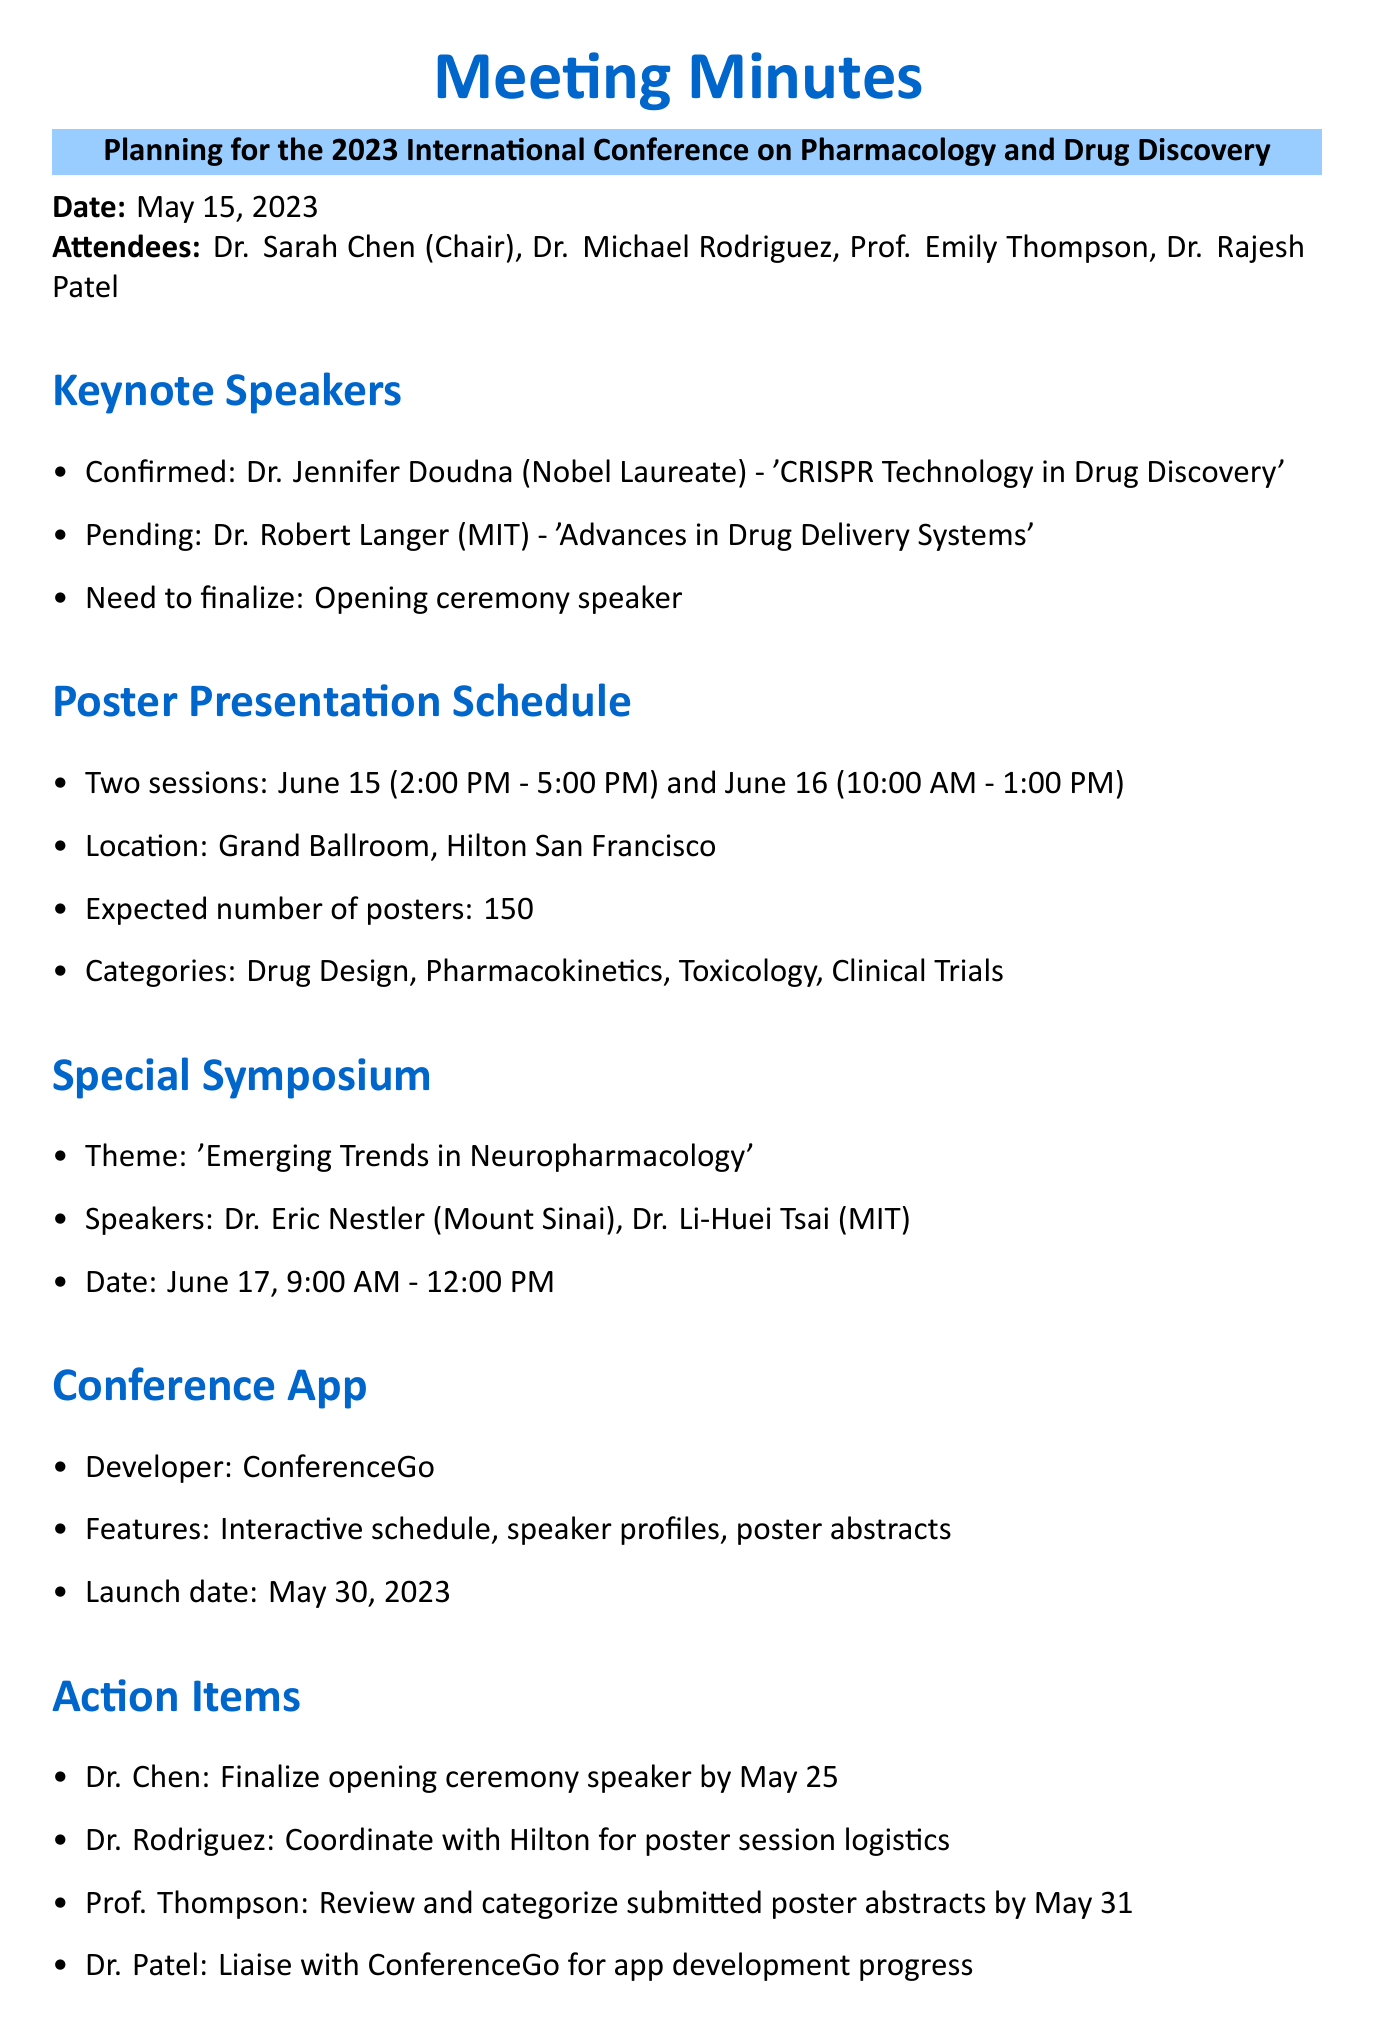What is the date of the meeting? The date of the meeting is specified in the document as May 15, 2023.
Answer: May 15, 2023 Who is the confirmed keynote speaker? The document mentions Dr. Jennifer Doudna as the confirmed keynote speaker.
Answer: Dr. Jennifer Doudna What is the expected number of posters at the conference? The expected number of posters is explicitly stated in the document as 150.
Answer: 150 What is the theme of the special symposium? The document specifies the theme of the special symposium as 'Emerging Trends in Neuropharmacology'.
Answer: Emerging Trends in Neuropharmacology When is the launch date of the conference app? The document provides the launch date of the conference app as May 30, 2023.
Answer: May 30, 2023 What is one of the categories for poster presentations? Categories for poster presentations are listed in the document, and one mentioned is 'Pharmacokinetics'.
Answer: Pharmacokinetics Who is responsible for reviewing and categorizing submitted poster abstracts? The document states that Prof. Thompson is responsible for this task.
Answer: Prof. Thompson What is the time for the first poster presentation session? The document indicates the time for the first session as 2:00 PM - 5:00 PM on June 15.
Answer: 2:00 PM - 5:00 PM Who is coordinating with Hilton for poster session logistics? The document assigns this responsibility to Dr. Rodriguez.
Answer: Dr. Rodriguez 